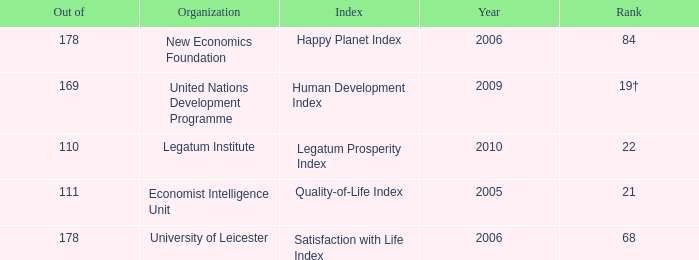What year for the legatum institute? 2010.0. 